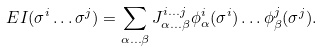<formula> <loc_0><loc_0><loc_500><loc_500>E I ( \sigma ^ { i } \dots \sigma ^ { j } ) = \sum _ { \alpha \dots \beta } J ^ { i \dots j } _ { \alpha \dots \beta } \phi ^ { i } _ { \alpha } ( \sigma ^ { i } ) \dots \phi ^ { j } _ { \beta } ( \sigma ^ { j } ) .</formula> 